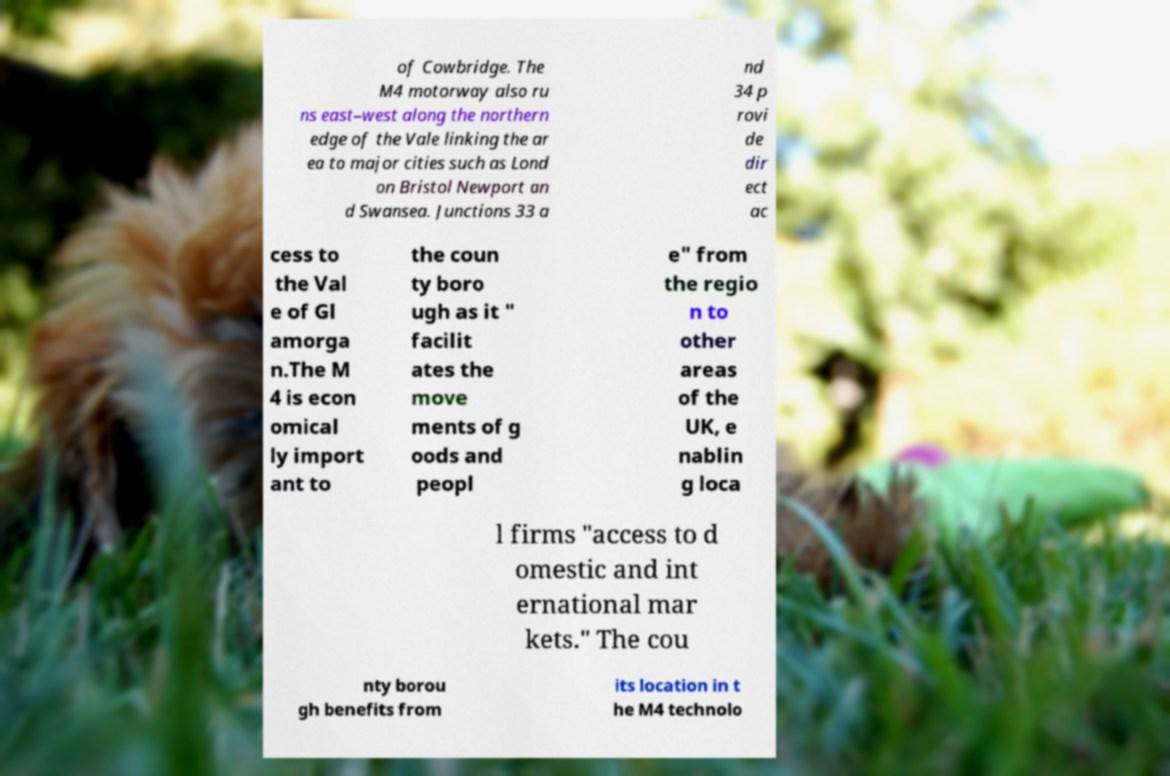Please identify and transcribe the text found in this image. of Cowbridge. The M4 motorway also ru ns east–west along the northern edge of the Vale linking the ar ea to major cities such as Lond on Bristol Newport an d Swansea. Junctions 33 a nd 34 p rovi de dir ect ac cess to the Val e of Gl amorga n.The M 4 is econ omical ly import ant to the coun ty boro ugh as it " facilit ates the move ments of g oods and peopl e" from the regio n to other areas of the UK, e nablin g loca l firms "access to d omestic and int ernational mar kets." The cou nty borou gh benefits from its location in t he M4 technolo 